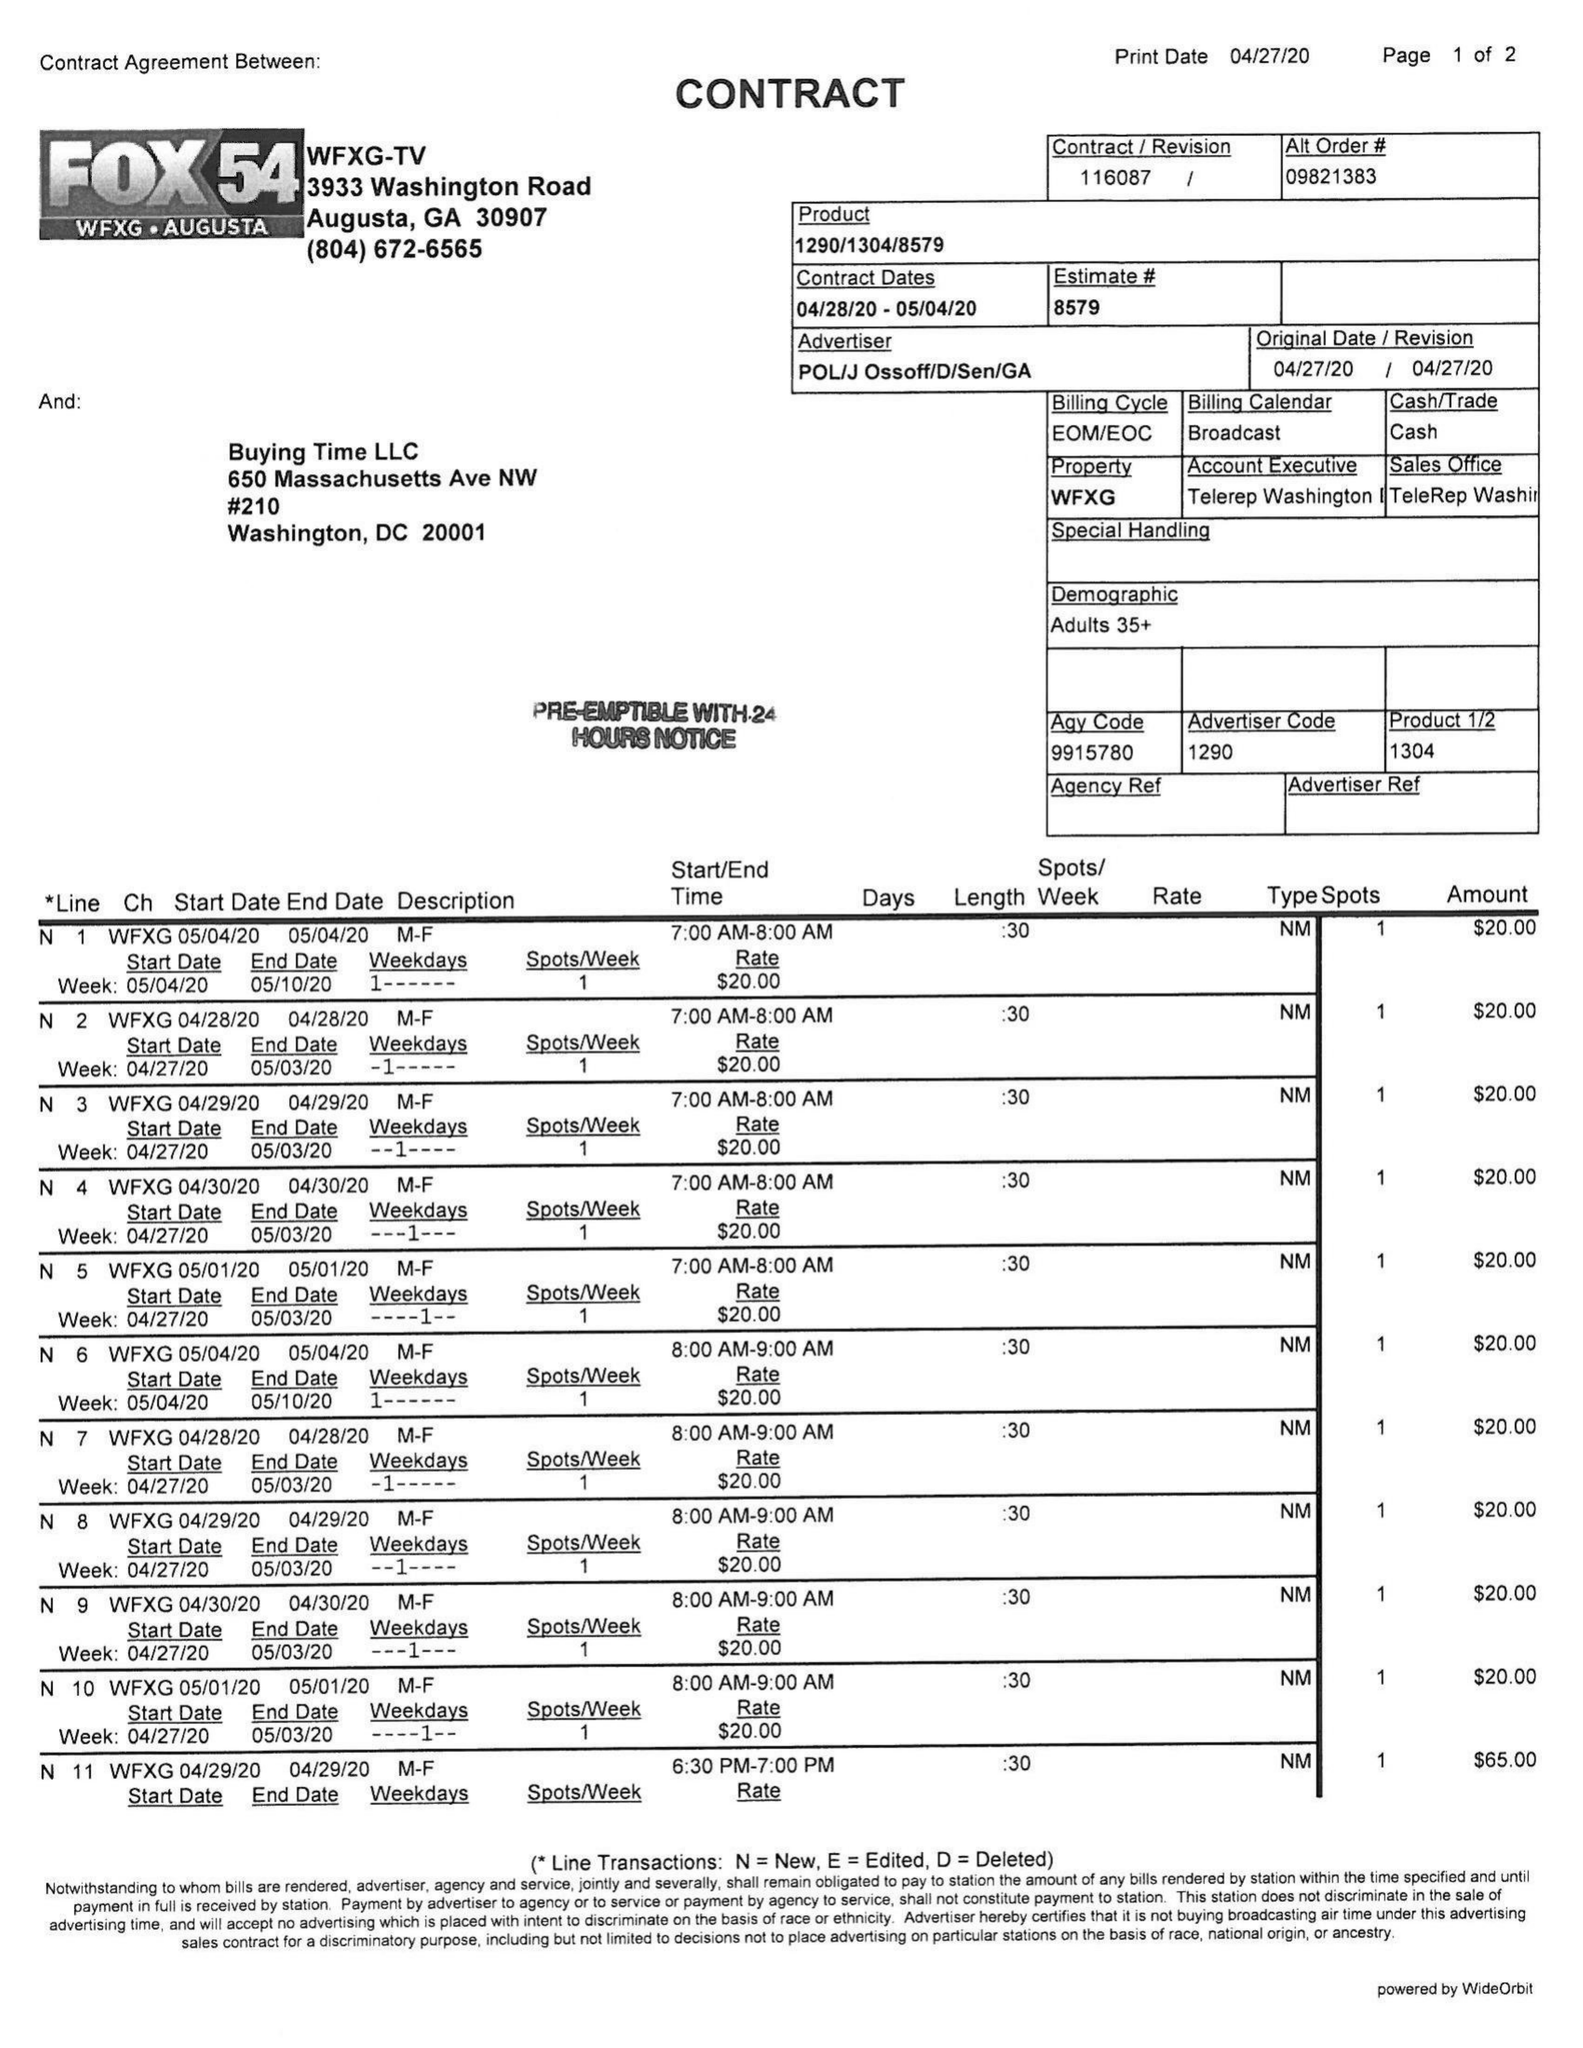What is the value for the advertiser?
Answer the question using a single word or phrase. POL/JOSSOFF/D/SEN/GA 